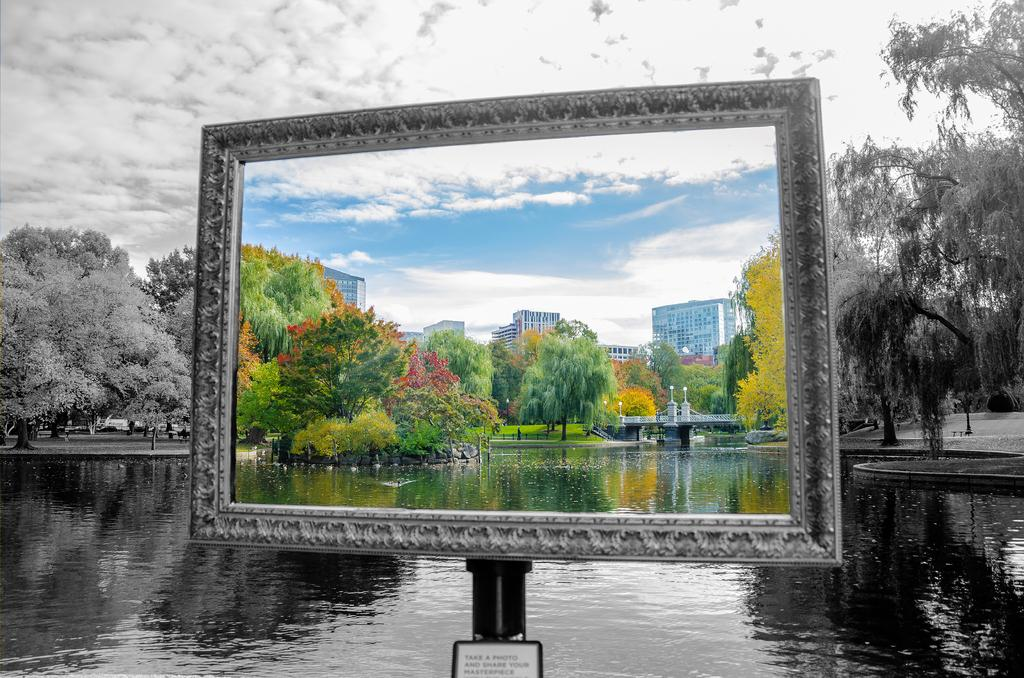What type of structures can be seen in the image? There are buildings in the image. What type of vegetation is present in the image? There are trees in the image. What natural element is visible in the image? There is water visible in the image. How would you describe the sky in the image? The sky is blue and cloudy in the image. Can you describe the background of the image? Trees, water, and a cloudy sky are present in the background of the image. What type of bird is wearing a stocking in the image? There is no bird or stocking present in the image. What color is the butter on the tree in the image? There is no butter present in the image, and trees are the only vegetation mentioned. 